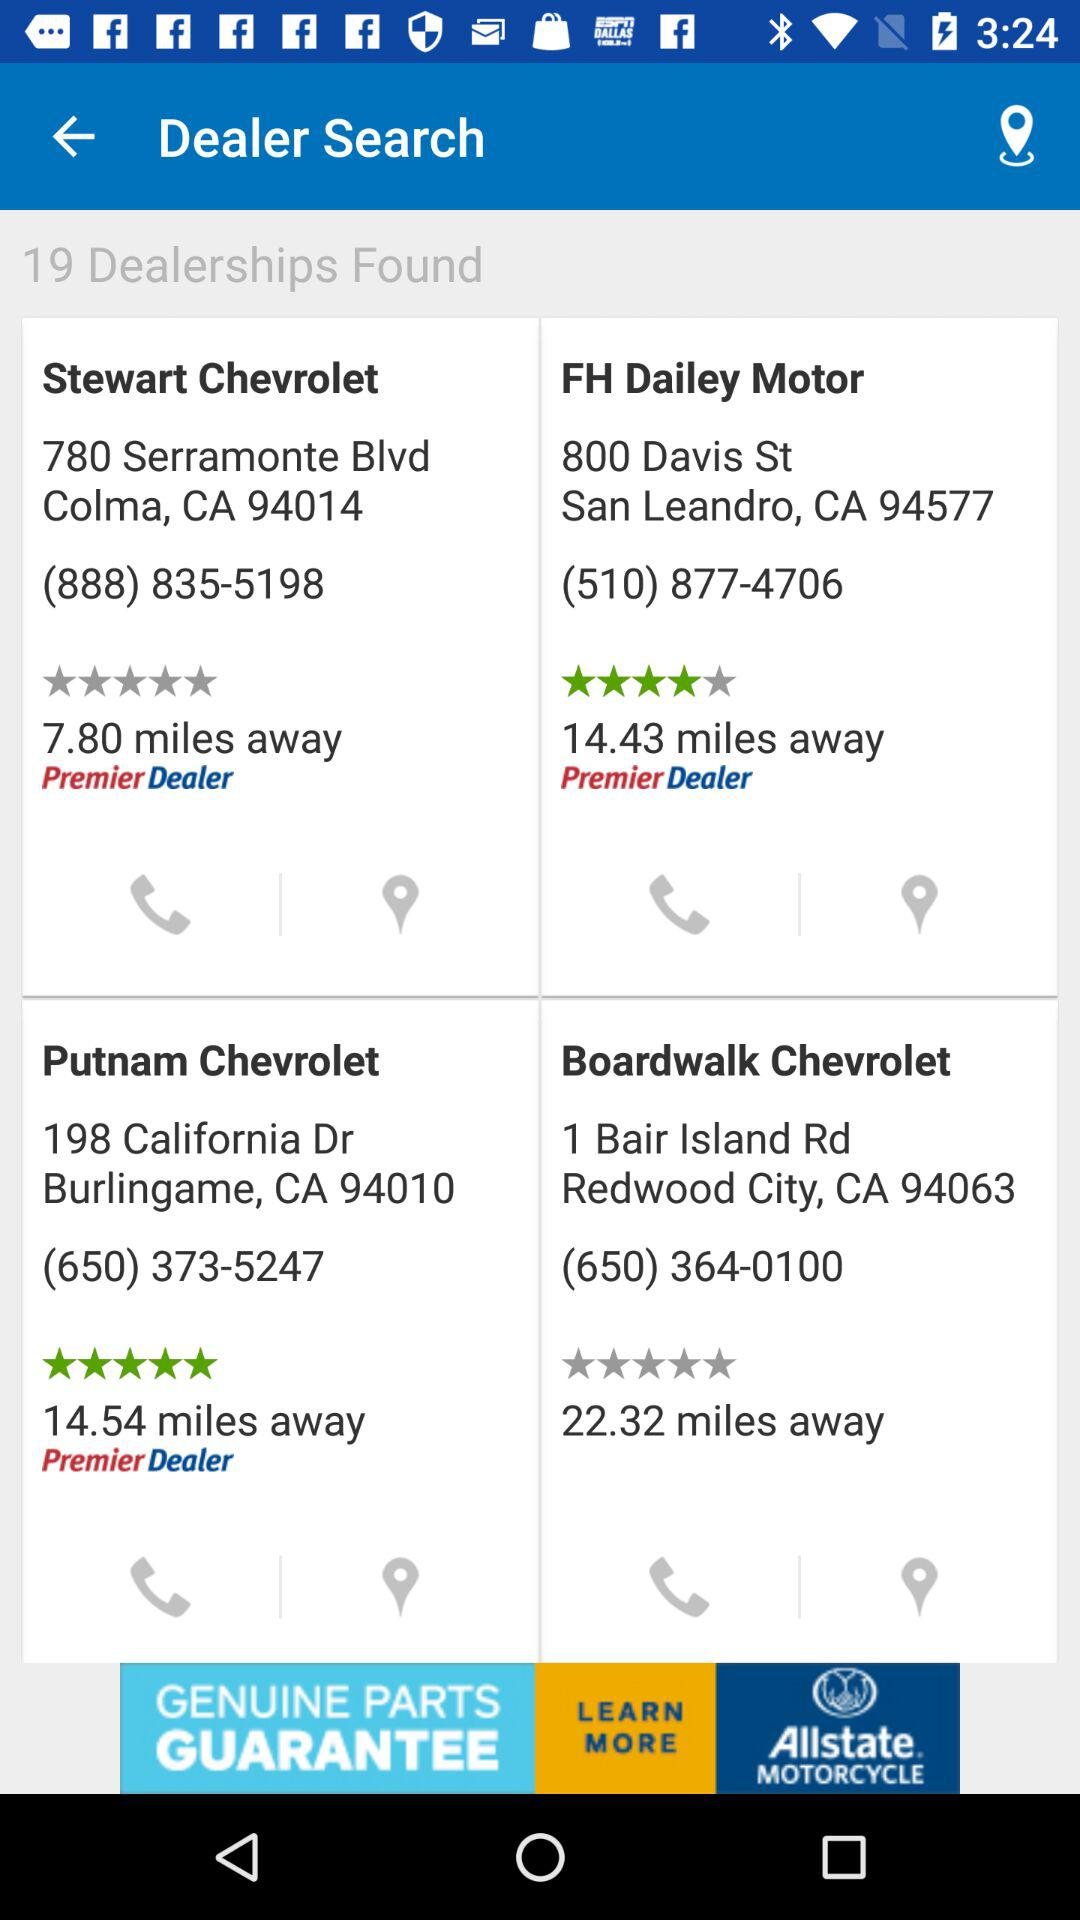What is the distance between "Putnam Chevrolet" and my location? The distance between "Putnam Chevrolet" and my location is 14.54 miles. 